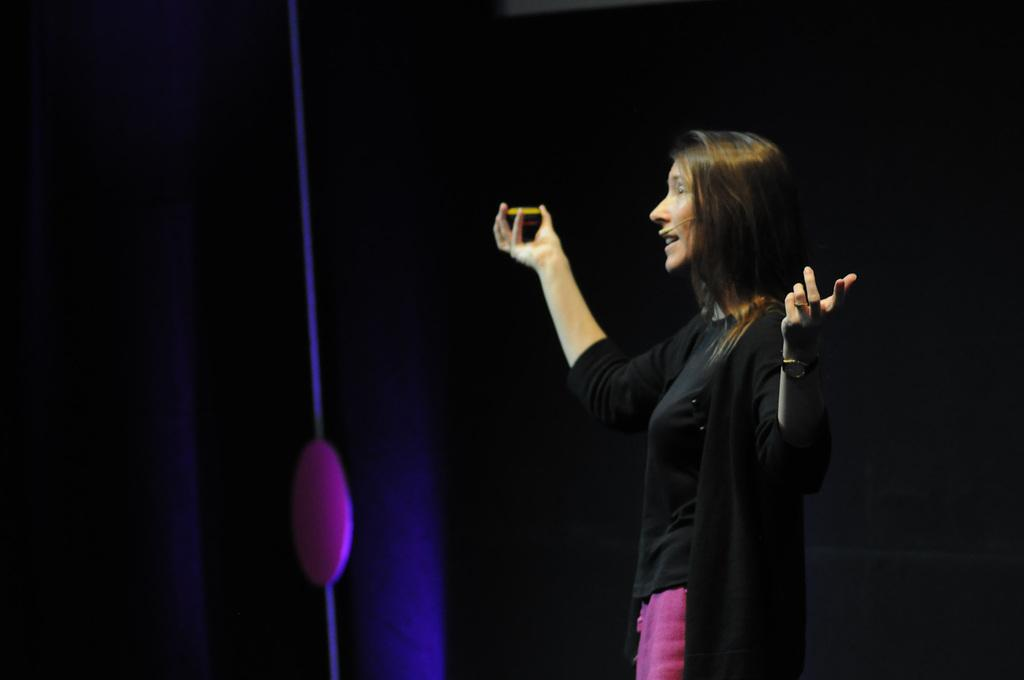Who is the main subject in the image? There is a woman in the image. What is the woman doing in the image? The woman is standing and speaking with the help of a microphone. What is the woman holding in one hand? The woman is holding something in one hand, but the specific object is not mentioned in the facts. How many balls are visible on the woman's wrist in the image? There are no balls visible on the woman's wrist in the image. 